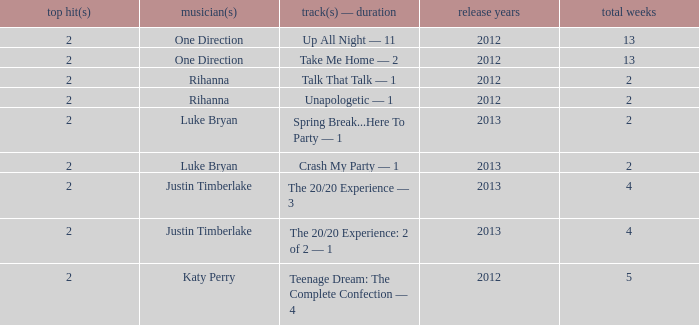What is the longest number of weeks any 1 song was at number #1? 13.0. 